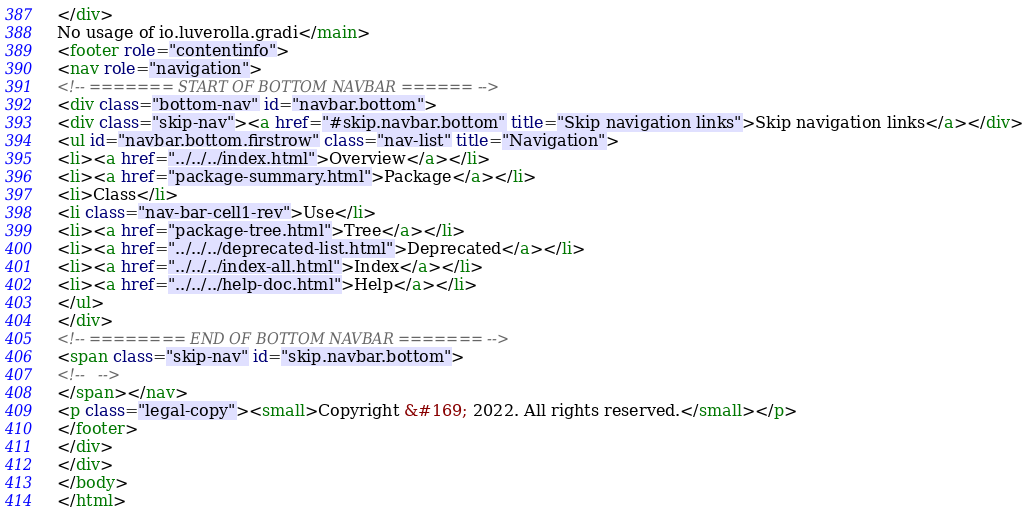Convert code to text. <code><loc_0><loc_0><loc_500><loc_500><_HTML_></div>
No usage of io.luverolla.gradi</main>
<footer role="contentinfo">
<nav role="navigation">
<!-- ======= START OF BOTTOM NAVBAR ====== -->
<div class="bottom-nav" id="navbar.bottom">
<div class="skip-nav"><a href="#skip.navbar.bottom" title="Skip navigation links">Skip navigation links</a></div>
<ul id="navbar.bottom.firstrow" class="nav-list" title="Navigation">
<li><a href="../../../index.html">Overview</a></li>
<li><a href="package-summary.html">Package</a></li>
<li>Class</li>
<li class="nav-bar-cell1-rev">Use</li>
<li><a href="package-tree.html">Tree</a></li>
<li><a href="../../../deprecated-list.html">Deprecated</a></li>
<li><a href="../../../index-all.html">Index</a></li>
<li><a href="../../../help-doc.html">Help</a></li>
</ul>
</div>
<!-- ======== END OF BOTTOM NAVBAR ======= -->
<span class="skip-nav" id="skip.navbar.bottom">
<!--   -->
</span></nav>
<p class="legal-copy"><small>Copyright &#169; 2022. All rights reserved.</small></p>
</footer>
</div>
</div>
</body>
</html>
</code> 